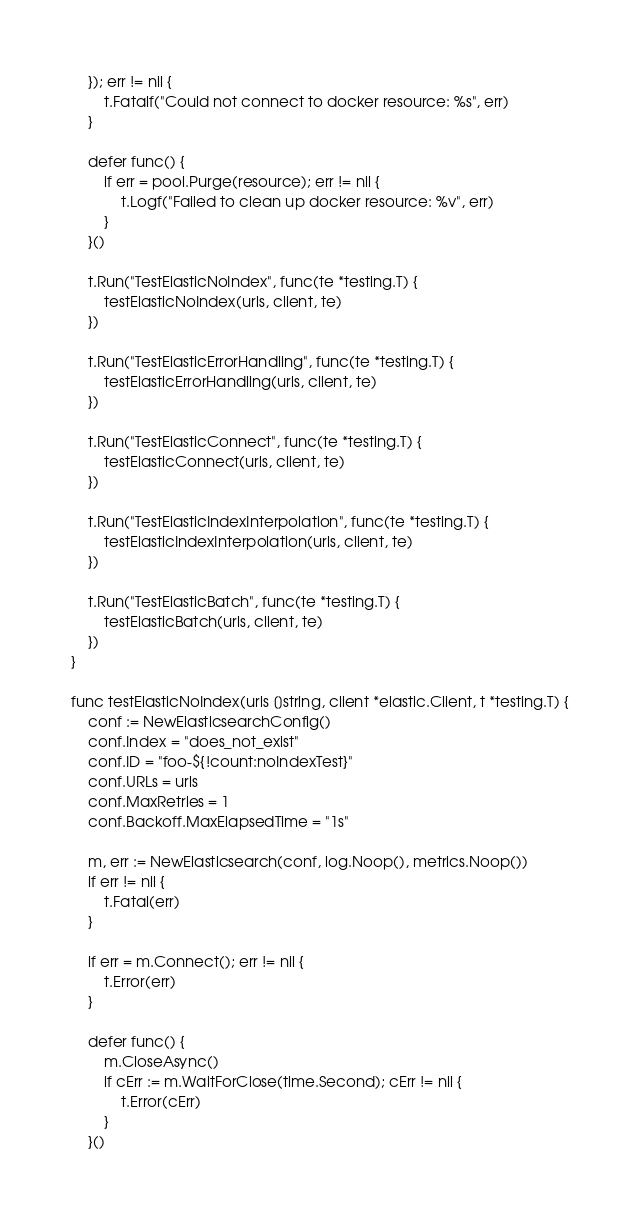Convert code to text. <code><loc_0><loc_0><loc_500><loc_500><_Go_>	}); err != nil {
		t.Fatalf("Could not connect to docker resource: %s", err)
	}

	defer func() {
		if err = pool.Purge(resource); err != nil {
			t.Logf("Failed to clean up docker resource: %v", err)
		}
	}()

	t.Run("TestElasticNoIndex", func(te *testing.T) {
		testElasticNoIndex(urls, client, te)
	})

	t.Run("TestElasticErrorHandling", func(te *testing.T) {
		testElasticErrorHandling(urls, client, te)
	})

	t.Run("TestElasticConnect", func(te *testing.T) {
		testElasticConnect(urls, client, te)
	})

	t.Run("TestElasticIndexInterpolation", func(te *testing.T) {
		testElasticIndexInterpolation(urls, client, te)
	})

	t.Run("TestElasticBatch", func(te *testing.T) {
		testElasticBatch(urls, client, te)
	})
}

func testElasticNoIndex(urls []string, client *elastic.Client, t *testing.T) {
	conf := NewElasticsearchConfig()
	conf.Index = "does_not_exist"
	conf.ID = "foo-${!count:noIndexTest}"
	conf.URLs = urls
	conf.MaxRetries = 1
	conf.Backoff.MaxElapsedTime = "1s"

	m, err := NewElasticsearch(conf, log.Noop(), metrics.Noop())
	if err != nil {
		t.Fatal(err)
	}

	if err = m.Connect(); err != nil {
		t.Error(err)
	}

	defer func() {
		m.CloseAsync()
		if cErr := m.WaitForClose(time.Second); cErr != nil {
			t.Error(cErr)
		}
	}()
</code> 